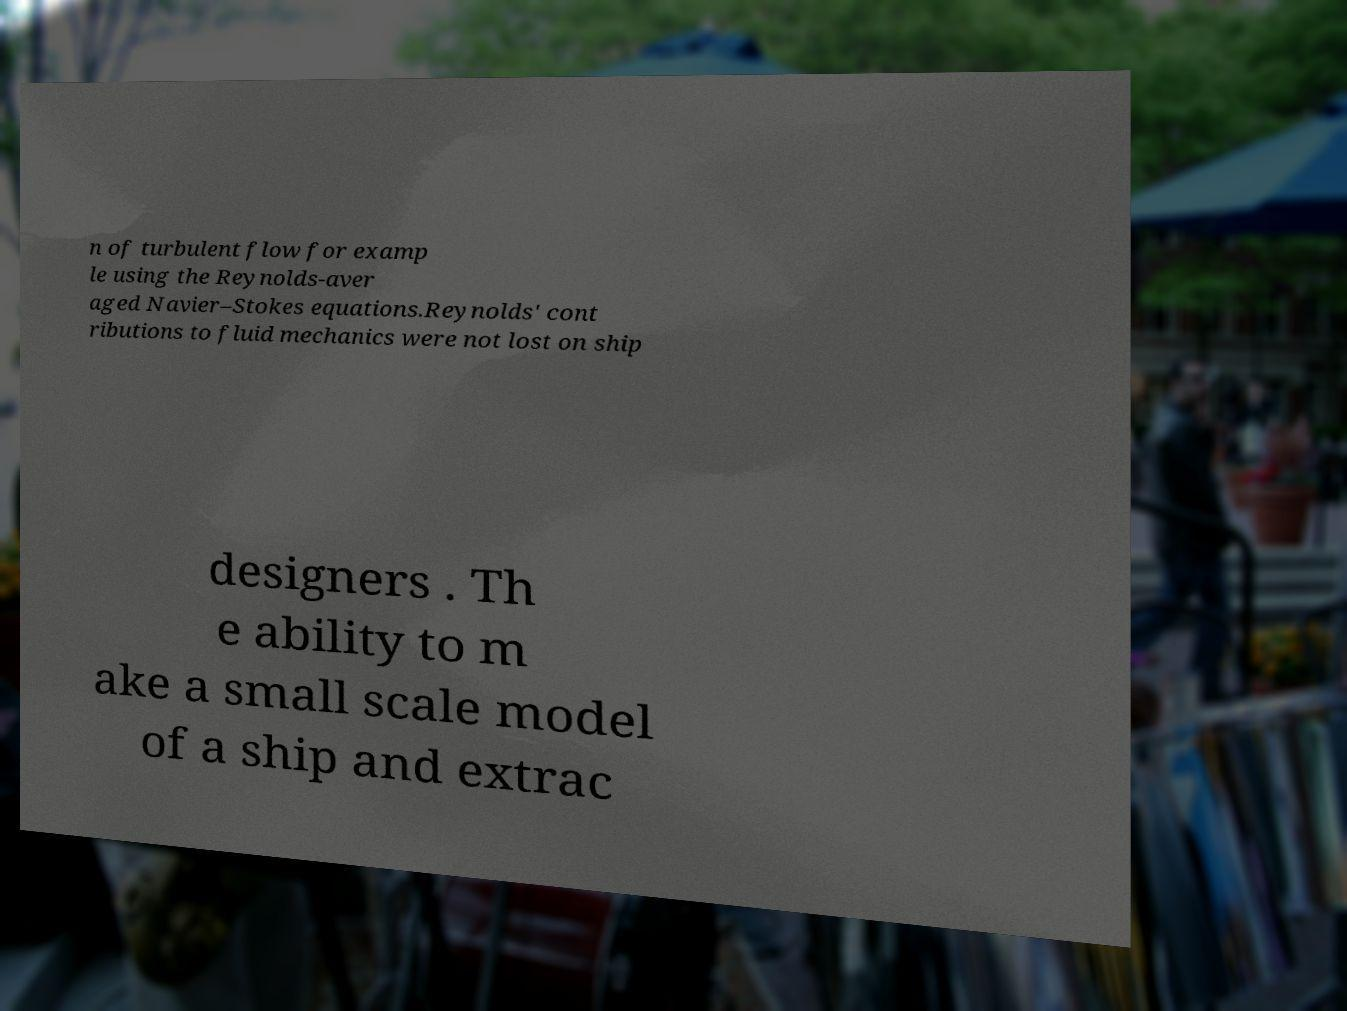For documentation purposes, I need the text within this image transcribed. Could you provide that? n of turbulent flow for examp le using the Reynolds-aver aged Navier–Stokes equations.Reynolds' cont ributions to fluid mechanics were not lost on ship designers . Th e ability to m ake a small scale model of a ship and extrac 